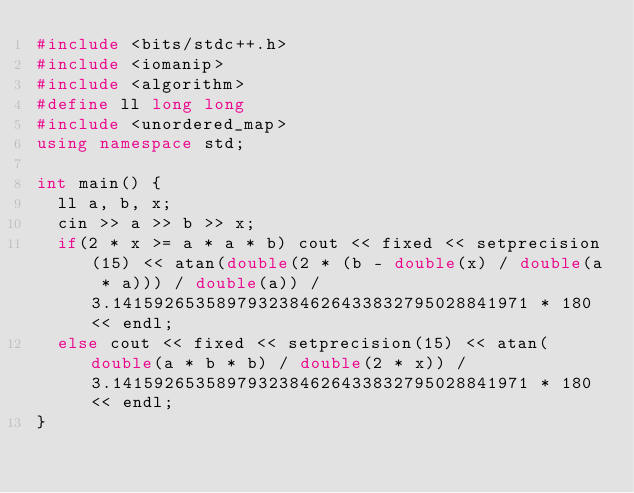<code> <loc_0><loc_0><loc_500><loc_500><_C++_>#include <bits/stdc++.h>
#include <iomanip>
#include <algorithm>
#define ll long long
#include <unordered_map>
using namespace std;
 
int main() {
  ll a, b, x;
  cin >> a >> b >> x;
  if(2 * x >= a * a * b) cout << fixed << setprecision(15) << atan(double(2 * (b - double(x) / double(a * a))) / double(a)) / 3.1415926535897932384626433832795028841971 * 180 << endl;
  else cout << fixed << setprecision(15) << atan(double(a * b * b) / double(2 * x)) / 3.1415926535897932384626433832795028841971 * 180 << endl;
}</code> 